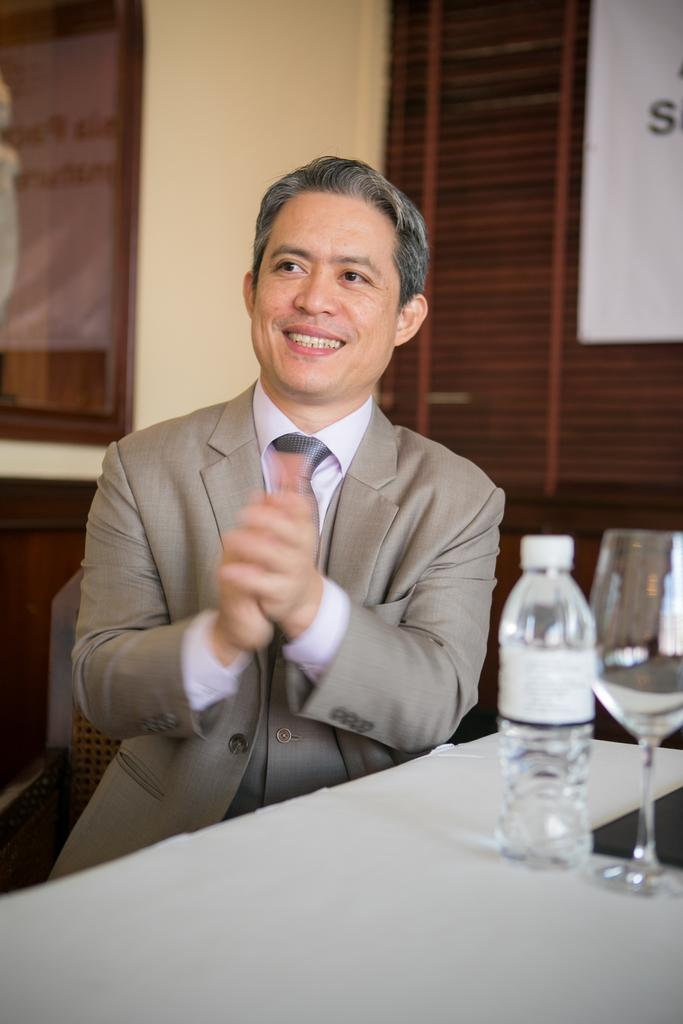Who is in the image? There is a man in the image. What is the man doing in the image? The man is sitting on a chair. What expression does the man have in the image? The man is smiling. What is in front of the man in the image? There is a table in front of the man. What is on the table in the image? There is a water bottle on the table. What can be seen on the wooden wall behind the man? There are water glands on the wooden wall behind the man. What type of bell can be heard ringing in the image? There is no bell present in the image, and therefore no sound can be heard. 